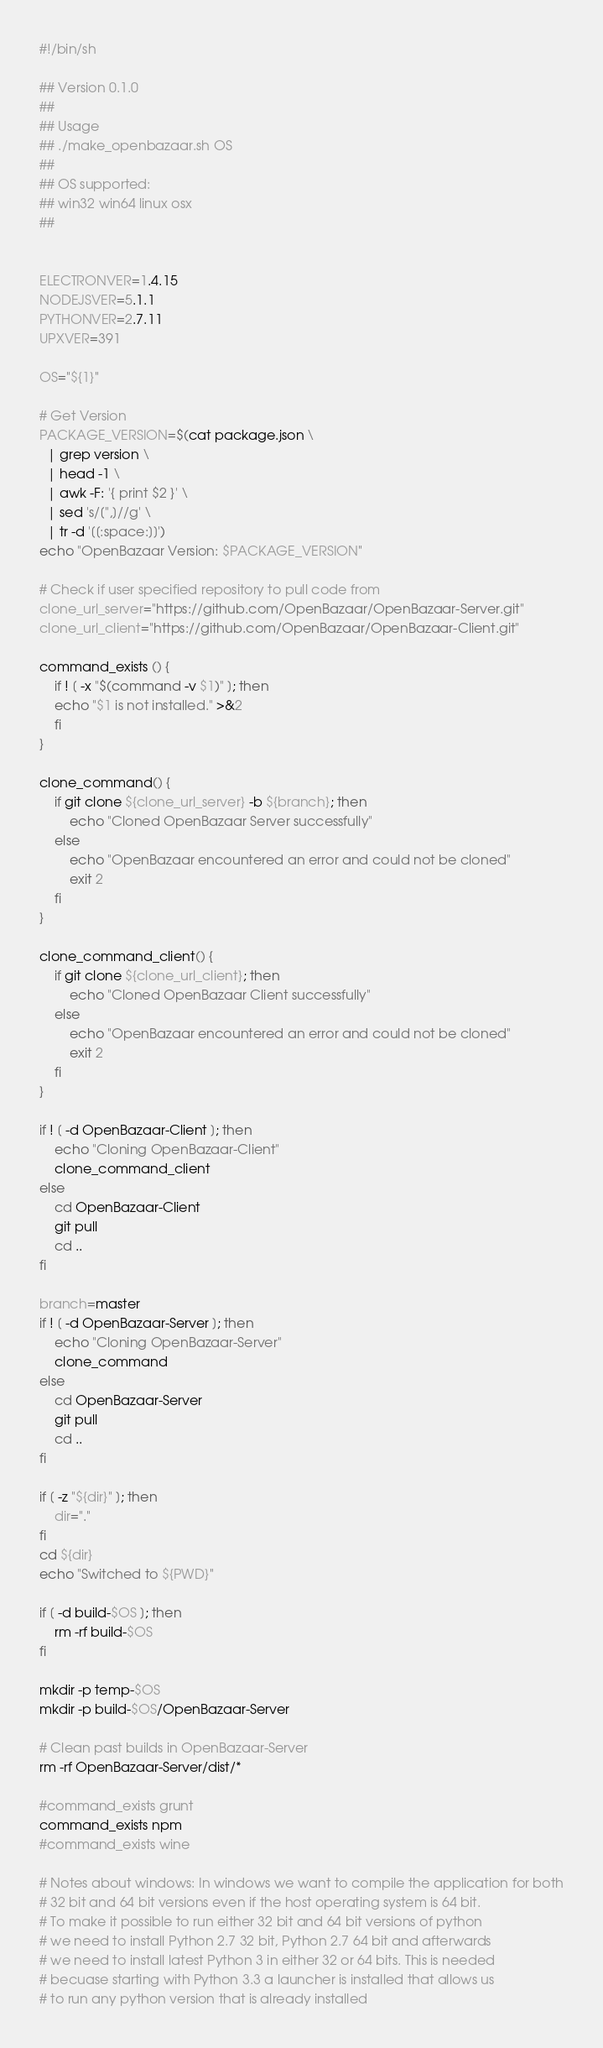<code> <loc_0><loc_0><loc_500><loc_500><_Bash_>#!/bin/sh

## Version 0.1.0
##
## Usage
## ./make_openbazaar.sh OS
##
## OS supported:
## win32 win64 linux osx
##


ELECTRONVER=1.4.15
NODEJSVER=5.1.1
PYTHONVER=2.7.11
UPXVER=391

OS="${1}"

# Get Version
PACKAGE_VERSION=$(cat package.json \
  | grep version \
  | head -1 \
  | awk -F: '{ print $2 }' \
  | sed 's/[",]//g' \
  | tr -d '[[:space:]]')
echo "OpenBazaar Version: $PACKAGE_VERSION"

# Check if user specified repository to pull code from
clone_url_server="https://github.com/OpenBazaar/OpenBazaar-Server.git"
clone_url_client="https://github.com/OpenBazaar/OpenBazaar-Client.git"

command_exists () {
    if ! [ -x "$(command -v $1)" ]; then
 	echo "$1 is not installed." >&2
    fi
}

clone_command() {
    if git clone ${clone_url_server} -b ${branch}; then
        echo "Cloned OpenBazaar Server successfully"
    else
        echo "OpenBazaar encountered an error and could not be cloned"
        exit 2
    fi
}

clone_command_client() {
    if git clone ${clone_url_client}; then
        echo "Cloned OpenBazaar Client successfully"
    else
        echo "OpenBazaar encountered an error and could not be cloned"
        exit 2
    fi
}

if ! [ -d OpenBazaar-Client ]; then
	echo "Cloning OpenBazaar-Client"
	clone_command_client
else
    cd OpenBazaar-Client
    git pull
    cd ..
fi

branch=master
if ! [ -d OpenBazaar-Server ]; then
    echo "Cloning OpenBazaar-Server"
    clone_command
else
    cd OpenBazaar-Server
    git pull
    cd ..
fi

if [ -z "${dir}" ]; then
    dir="."
fi
cd ${dir}
echo "Switched to ${PWD}"

if [ -d build-$OS ]; then
    rm -rf build-$OS
fi

mkdir -p temp-$OS
mkdir -p build-$OS/OpenBazaar-Server

# Clean past builds in OpenBazaar-Server
rm -rf OpenBazaar-Server/dist/*

#command_exists grunt
command_exists npm
#command_exists wine

# Notes about windows: In windows we want to compile the application for both
# 32 bit and 64 bit versions even if the host operating system is 64 bit.
# To make it possible to run either 32 bit and 64 bit versions of python
# we need to install Python 2.7 32 bit, Python 2.7 64 bit and afterwards
# we need to install latest Python 3 in either 32 or 64 bits. This is needed
# becuase starting with Python 3.3 a launcher is installed that allows us
# to run any python version that is already installed</code> 